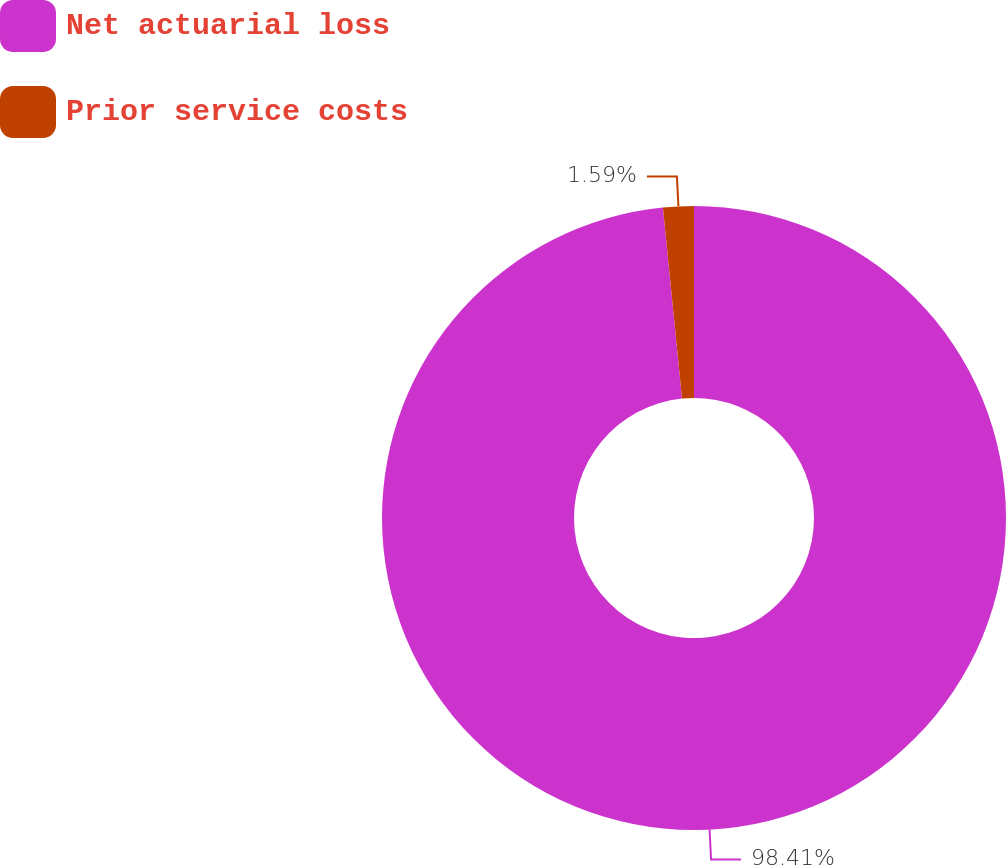<chart> <loc_0><loc_0><loc_500><loc_500><pie_chart><fcel>Net actuarial loss<fcel>Prior service costs<nl><fcel>98.41%<fcel>1.59%<nl></chart> 